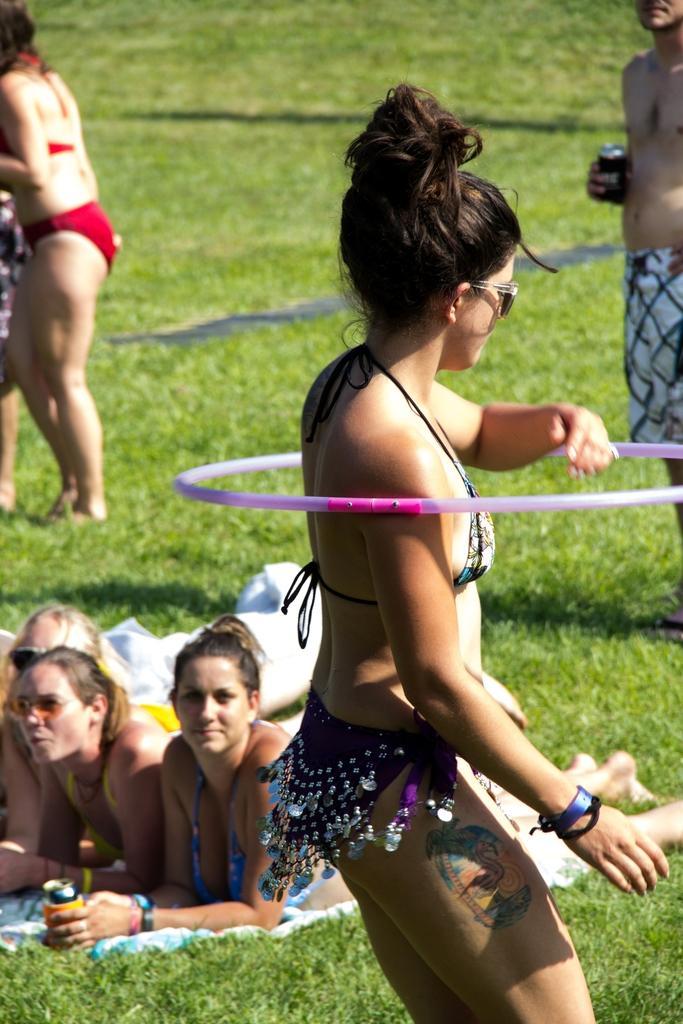Describe this image in one or two sentences. In this image there is a girl performing hula hoops, behind the girl there are a few people standing and there are few women laid on the surface of the grass. 